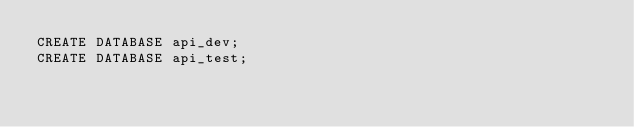<code> <loc_0><loc_0><loc_500><loc_500><_SQL_>CREATE DATABASE api_dev;
CREATE DATABASE api_test;</code> 